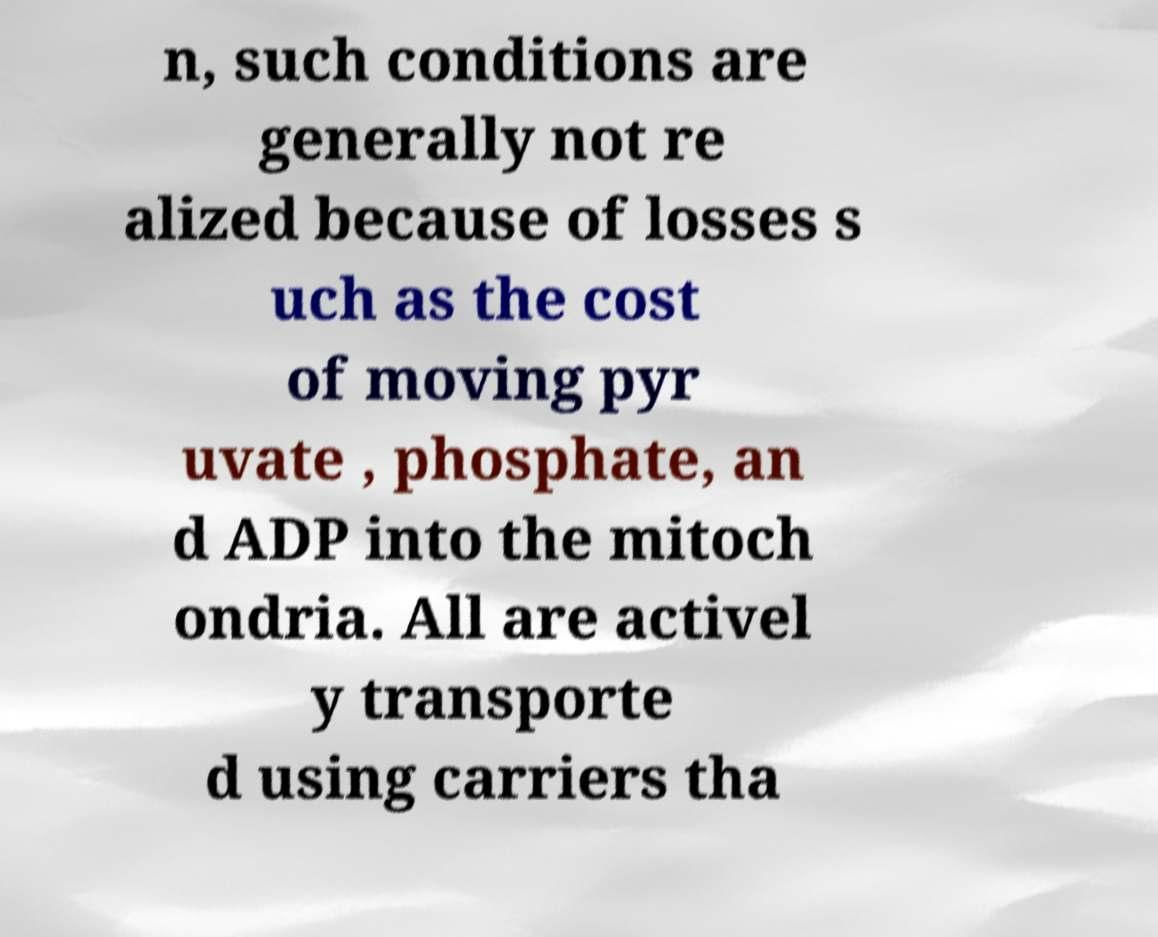There's text embedded in this image that I need extracted. Can you transcribe it verbatim? n, such conditions are generally not re alized because of losses s uch as the cost of moving pyr uvate , phosphate, an d ADP into the mitoch ondria. All are activel y transporte d using carriers tha 